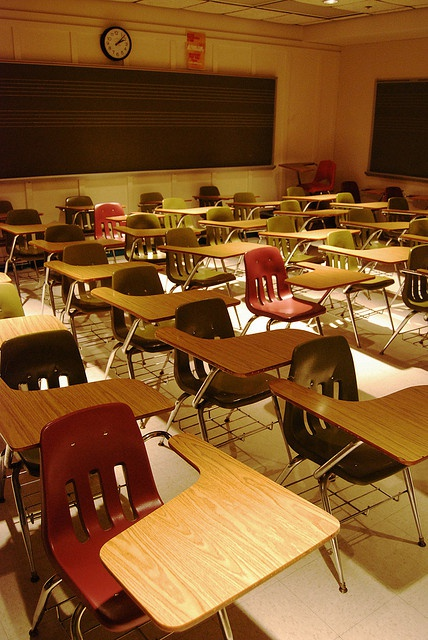Describe the objects in this image and their specific colors. I can see chair in maroon, black, and brown tones, chair in maroon, black, and olive tones, chair in maroon, black, and olive tones, chair in maroon, black, olive, and tan tones, and chair in maroon, black, ivory, and olive tones in this image. 